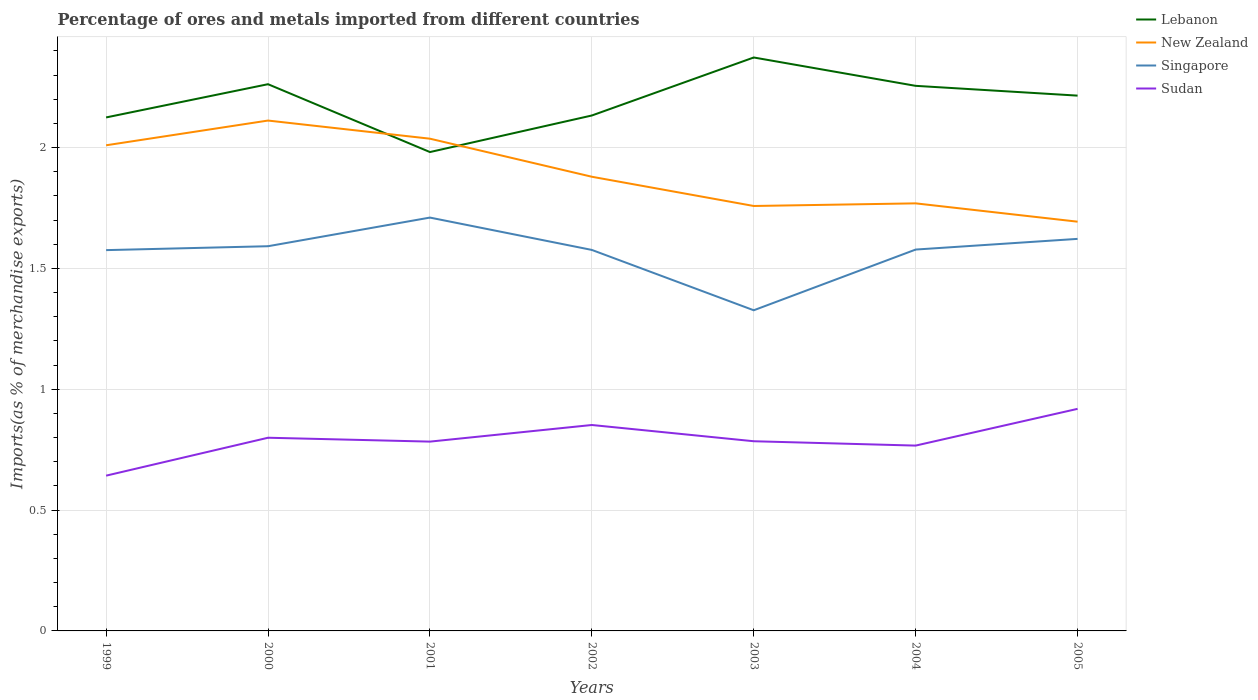Across all years, what is the maximum percentage of imports to different countries in Singapore?
Provide a short and direct response. 1.33. What is the total percentage of imports to different countries in Singapore in the graph?
Ensure brevity in your answer.  0.09. What is the difference between the highest and the second highest percentage of imports to different countries in Lebanon?
Offer a very short reply. 0.39. What is the difference between the highest and the lowest percentage of imports to different countries in New Zealand?
Your answer should be very brief. 3. Is the percentage of imports to different countries in Singapore strictly greater than the percentage of imports to different countries in Lebanon over the years?
Provide a short and direct response. Yes. How many years are there in the graph?
Make the answer very short. 7. Are the values on the major ticks of Y-axis written in scientific E-notation?
Give a very brief answer. No. Does the graph contain any zero values?
Provide a short and direct response. No. Where does the legend appear in the graph?
Give a very brief answer. Top right. How many legend labels are there?
Ensure brevity in your answer.  4. What is the title of the graph?
Keep it short and to the point. Percentage of ores and metals imported from different countries. What is the label or title of the Y-axis?
Your response must be concise. Imports(as % of merchandise exports). What is the Imports(as % of merchandise exports) of Lebanon in 1999?
Your response must be concise. 2.12. What is the Imports(as % of merchandise exports) of New Zealand in 1999?
Your answer should be compact. 2.01. What is the Imports(as % of merchandise exports) of Singapore in 1999?
Your response must be concise. 1.58. What is the Imports(as % of merchandise exports) in Sudan in 1999?
Your answer should be compact. 0.64. What is the Imports(as % of merchandise exports) of Lebanon in 2000?
Make the answer very short. 2.26. What is the Imports(as % of merchandise exports) of New Zealand in 2000?
Your answer should be very brief. 2.11. What is the Imports(as % of merchandise exports) in Singapore in 2000?
Your answer should be very brief. 1.59. What is the Imports(as % of merchandise exports) of Sudan in 2000?
Your answer should be compact. 0.8. What is the Imports(as % of merchandise exports) of Lebanon in 2001?
Offer a very short reply. 1.98. What is the Imports(as % of merchandise exports) in New Zealand in 2001?
Your answer should be very brief. 2.04. What is the Imports(as % of merchandise exports) of Singapore in 2001?
Provide a short and direct response. 1.71. What is the Imports(as % of merchandise exports) in Sudan in 2001?
Your answer should be very brief. 0.78. What is the Imports(as % of merchandise exports) in Lebanon in 2002?
Your response must be concise. 2.13. What is the Imports(as % of merchandise exports) in New Zealand in 2002?
Your response must be concise. 1.88. What is the Imports(as % of merchandise exports) in Singapore in 2002?
Give a very brief answer. 1.58. What is the Imports(as % of merchandise exports) of Sudan in 2002?
Your response must be concise. 0.85. What is the Imports(as % of merchandise exports) in Lebanon in 2003?
Your answer should be very brief. 2.37. What is the Imports(as % of merchandise exports) of New Zealand in 2003?
Your response must be concise. 1.76. What is the Imports(as % of merchandise exports) in Singapore in 2003?
Offer a very short reply. 1.33. What is the Imports(as % of merchandise exports) of Sudan in 2003?
Offer a terse response. 0.78. What is the Imports(as % of merchandise exports) in Lebanon in 2004?
Give a very brief answer. 2.26. What is the Imports(as % of merchandise exports) in New Zealand in 2004?
Provide a succinct answer. 1.77. What is the Imports(as % of merchandise exports) of Singapore in 2004?
Your answer should be compact. 1.58. What is the Imports(as % of merchandise exports) of Sudan in 2004?
Provide a succinct answer. 0.77. What is the Imports(as % of merchandise exports) in Lebanon in 2005?
Your answer should be very brief. 2.21. What is the Imports(as % of merchandise exports) in New Zealand in 2005?
Provide a succinct answer. 1.69. What is the Imports(as % of merchandise exports) in Singapore in 2005?
Make the answer very short. 1.62. What is the Imports(as % of merchandise exports) of Sudan in 2005?
Provide a short and direct response. 0.92. Across all years, what is the maximum Imports(as % of merchandise exports) of Lebanon?
Your response must be concise. 2.37. Across all years, what is the maximum Imports(as % of merchandise exports) of New Zealand?
Ensure brevity in your answer.  2.11. Across all years, what is the maximum Imports(as % of merchandise exports) of Singapore?
Your answer should be very brief. 1.71. Across all years, what is the maximum Imports(as % of merchandise exports) of Sudan?
Your answer should be compact. 0.92. Across all years, what is the minimum Imports(as % of merchandise exports) in Lebanon?
Make the answer very short. 1.98. Across all years, what is the minimum Imports(as % of merchandise exports) in New Zealand?
Your answer should be compact. 1.69. Across all years, what is the minimum Imports(as % of merchandise exports) of Singapore?
Your answer should be compact. 1.33. Across all years, what is the minimum Imports(as % of merchandise exports) in Sudan?
Keep it short and to the point. 0.64. What is the total Imports(as % of merchandise exports) of Lebanon in the graph?
Offer a very short reply. 15.34. What is the total Imports(as % of merchandise exports) of New Zealand in the graph?
Make the answer very short. 13.26. What is the total Imports(as % of merchandise exports) in Singapore in the graph?
Your response must be concise. 10.98. What is the total Imports(as % of merchandise exports) in Sudan in the graph?
Provide a succinct answer. 5.55. What is the difference between the Imports(as % of merchandise exports) of Lebanon in 1999 and that in 2000?
Your answer should be very brief. -0.14. What is the difference between the Imports(as % of merchandise exports) in New Zealand in 1999 and that in 2000?
Your answer should be very brief. -0.1. What is the difference between the Imports(as % of merchandise exports) in Singapore in 1999 and that in 2000?
Your response must be concise. -0.02. What is the difference between the Imports(as % of merchandise exports) of Sudan in 1999 and that in 2000?
Your answer should be very brief. -0.16. What is the difference between the Imports(as % of merchandise exports) in Lebanon in 1999 and that in 2001?
Keep it short and to the point. 0.14. What is the difference between the Imports(as % of merchandise exports) of New Zealand in 1999 and that in 2001?
Ensure brevity in your answer.  -0.03. What is the difference between the Imports(as % of merchandise exports) of Singapore in 1999 and that in 2001?
Give a very brief answer. -0.13. What is the difference between the Imports(as % of merchandise exports) in Sudan in 1999 and that in 2001?
Ensure brevity in your answer.  -0.14. What is the difference between the Imports(as % of merchandise exports) of Lebanon in 1999 and that in 2002?
Keep it short and to the point. -0.01. What is the difference between the Imports(as % of merchandise exports) in New Zealand in 1999 and that in 2002?
Your answer should be compact. 0.13. What is the difference between the Imports(as % of merchandise exports) of Singapore in 1999 and that in 2002?
Keep it short and to the point. -0. What is the difference between the Imports(as % of merchandise exports) in Sudan in 1999 and that in 2002?
Provide a succinct answer. -0.21. What is the difference between the Imports(as % of merchandise exports) in Lebanon in 1999 and that in 2003?
Provide a short and direct response. -0.25. What is the difference between the Imports(as % of merchandise exports) of New Zealand in 1999 and that in 2003?
Your answer should be very brief. 0.25. What is the difference between the Imports(as % of merchandise exports) in Singapore in 1999 and that in 2003?
Your answer should be compact. 0.25. What is the difference between the Imports(as % of merchandise exports) of Sudan in 1999 and that in 2003?
Provide a succinct answer. -0.14. What is the difference between the Imports(as % of merchandise exports) of Lebanon in 1999 and that in 2004?
Your response must be concise. -0.13. What is the difference between the Imports(as % of merchandise exports) of New Zealand in 1999 and that in 2004?
Your answer should be very brief. 0.24. What is the difference between the Imports(as % of merchandise exports) of Singapore in 1999 and that in 2004?
Your answer should be compact. -0. What is the difference between the Imports(as % of merchandise exports) in Sudan in 1999 and that in 2004?
Offer a terse response. -0.12. What is the difference between the Imports(as % of merchandise exports) of Lebanon in 1999 and that in 2005?
Your response must be concise. -0.09. What is the difference between the Imports(as % of merchandise exports) of New Zealand in 1999 and that in 2005?
Provide a succinct answer. 0.32. What is the difference between the Imports(as % of merchandise exports) of Singapore in 1999 and that in 2005?
Your answer should be compact. -0.05. What is the difference between the Imports(as % of merchandise exports) of Sudan in 1999 and that in 2005?
Ensure brevity in your answer.  -0.28. What is the difference between the Imports(as % of merchandise exports) of Lebanon in 2000 and that in 2001?
Make the answer very short. 0.28. What is the difference between the Imports(as % of merchandise exports) of New Zealand in 2000 and that in 2001?
Offer a terse response. 0.07. What is the difference between the Imports(as % of merchandise exports) of Singapore in 2000 and that in 2001?
Provide a succinct answer. -0.12. What is the difference between the Imports(as % of merchandise exports) in Sudan in 2000 and that in 2001?
Your response must be concise. 0.02. What is the difference between the Imports(as % of merchandise exports) of Lebanon in 2000 and that in 2002?
Give a very brief answer. 0.13. What is the difference between the Imports(as % of merchandise exports) in New Zealand in 2000 and that in 2002?
Ensure brevity in your answer.  0.23. What is the difference between the Imports(as % of merchandise exports) of Singapore in 2000 and that in 2002?
Keep it short and to the point. 0.02. What is the difference between the Imports(as % of merchandise exports) in Sudan in 2000 and that in 2002?
Your answer should be compact. -0.05. What is the difference between the Imports(as % of merchandise exports) of Lebanon in 2000 and that in 2003?
Your answer should be compact. -0.11. What is the difference between the Imports(as % of merchandise exports) in New Zealand in 2000 and that in 2003?
Your answer should be very brief. 0.35. What is the difference between the Imports(as % of merchandise exports) of Singapore in 2000 and that in 2003?
Your answer should be very brief. 0.27. What is the difference between the Imports(as % of merchandise exports) of Sudan in 2000 and that in 2003?
Provide a succinct answer. 0.01. What is the difference between the Imports(as % of merchandise exports) in Lebanon in 2000 and that in 2004?
Keep it short and to the point. 0.01. What is the difference between the Imports(as % of merchandise exports) of New Zealand in 2000 and that in 2004?
Make the answer very short. 0.34. What is the difference between the Imports(as % of merchandise exports) of Singapore in 2000 and that in 2004?
Provide a short and direct response. 0.01. What is the difference between the Imports(as % of merchandise exports) of Sudan in 2000 and that in 2004?
Make the answer very short. 0.03. What is the difference between the Imports(as % of merchandise exports) in Lebanon in 2000 and that in 2005?
Provide a succinct answer. 0.05. What is the difference between the Imports(as % of merchandise exports) of New Zealand in 2000 and that in 2005?
Ensure brevity in your answer.  0.42. What is the difference between the Imports(as % of merchandise exports) in Singapore in 2000 and that in 2005?
Provide a succinct answer. -0.03. What is the difference between the Imports(as % of merchandise exports) of Sudan in 2000 and that in 2005?
Offer a very short reply. -0.12. What is the difference between the Imports(as % of merchandise exports) of Lebanon in 2001 and that in 2002?
Offer a very short reply. -0.15. What is the difference between the Imports(as % of merchandise exports) in New Zealand in 2001 and that in 2002?
Offer a terse response. 0.16. What is the difference between the Imports(as % of merchandise exports) in Singapore in 2001 and that in 2002?
Ensure brevity in your answer.  0.13. What is the difference between the Imports(as % of merchandise exports) of Sudan in 2001 and that in 2002?
Offer a very short reply. -0.07. What is the difference between the Imports(as % of merchandise exports) in Lebanon in 2001 and that in 2003?
Your response must be concise. -0.39. What is the difference between the Imports(as % of merchandise exports) of New Zealand in 2001 and that in 2003?
Make the answer very short. 0.28. What is the difference between the Imports(as % of merchandise exports) in Singapore in 2001 and that in 2003?
Make the answer very short. 0.38. What is the difference between the Imports(as % of merchandise exports) in Sudan in 2001 and that in 2003?
Provide a succinct answer. -0. What is the difference between the Imports(as % of merchandise exports) in Lebanon in 2001 and that in 2004?
Your response must be concise. -0.27. What is the difference between the Imports(as % of merchandise exports) in New Zealand in 2001 and that in 2004?
Your response must be concise. 0.27. What is the difference between the Imports(as % of merchandise exports) in Singapore in 2001 and that in 2004?
Offer a terse response. 0.13. What is the difference between the Imports(as % of merchandise exports) in Sudan in 2001 and that in 2004?
Make the answer very short. 0.02. What is the difference between the Imports(as % of merchandise exports) in Lebanon in 2001 and that in 2005?
Ensure brevity in your answer.  -0.23. What is the difference between the Imports(as % of merchandise exports) of New Zealand in 2001 and that in 2005?
Keep it short and to the point. 0.34. What is the difference between the Imports(as % of merchandise exports) of Singapore in 2001 and that in 2005?
Offer a very short reply. 0.09. What is the difference between the Imports(as % of merchandise exports) of Sudan in 2001 and that in 2005?
Provide a succinct answer. -0.14. What is the difference between the Imports(as % of merchandise exports) of Lebanon in 2002 and that in 2003?
Make the answer very short. -0.24. What is the difference between the Imports(as % of merchandise exports) of New Zealand in 2002 and that in 2003?
Offer a very short reply. 0.12. What is the difference between the Imports(as % of merchandise exports) of Singapore in 2002 and that in 2003?
Keep it short and to the point. 0.25. What is the difference between the Imports(as % of merchandise exports) of Sudan in 2002 and that in 2003?
Make the answer very short. 0.07. What is the difference between the Imports(as % of merchandise exports) in Lebanon in 2002 and that in 2004?
Offer a terse response. -0.12. What is the difference between the Imports(as % of merchandise exports) of New Zealand in 2002 and that in 2004?
Provide a succinct answer. 0.11. What is the difference between the Imports(as % of merchandise exports) of Singapore in 2002 and that in 2004?
Make the answer very short. -0. What is the difference between the Imports(as % of merchandise exports) of Sudan in 2002 and that in 2004?
Provide a short and direct response. 0.09. What is the difference between the Imports(as % of merchandise exports) of Lebanon in 2002 and that in 2005?
Provide a short and direct response. -0.08. What is the difference between the Imports(as % of merchandise exports) in New Zealand in 2002 and that in 2005?
Offer a terse response. 0.19. What is the difference between the Imports(as % of merchandise exports) in Singapore in 2002 and that in 2005?
Your answer should be compact. -0.05. What is the difference between the Imports(as % of merchandise exports) of Sudan in 2002 and that in 2005?
Your answer should be very brief. -0.07. What is the difference between the Imports(as % of merchandise exports) of Lebanon in 2003 and that in 2004?
Your response must be concise. 0.12. What is the difference between the Imports(as % of merchandise exports) in New Zealand in 2003 and that in 2004?
Provide a succinct answer. -0.01. What is the difference between the Imports(as % of merchandise exports) of Singapore in 2003 and that in 2004?
Your response must be concise. -0.25. What is the difference between the Imports(as % of merchandise exports) of Sudan in 2003 and that in 2004?
Make the answer very short. 0.02. What is the difference between the Imports(as % of merchandise exports) of Lebanon in 2003 and that in 2005?
Your response must be concise. 0.16. What is the difference between the Imports(as % of merchandise exports) of New Zealand in 2003 and that in 2005?
Give a very brief answer. 0.06. What is the difference between the Imports(as % of merchandise exports) in Singapore in 2003 and that in 2005?
Your answer should be very brief. -0.3. What is the difference between the Imports(as % of merchandise exports) of Sudan in 2003 and that in 2005?
Provide a succinct answer. -0.13. What is the difference between the Imports(as % of merchandise exports) in Lebanon in 2004 and that in 2005?
Ensure brevity in your answer.  0.04. What is the difference between the Imports(as % of merchandise exports) in New Zealand in 2004 and that in 2005?
Your answer should be very brief. 0.08. What is the difference between the Imports(as % of merchandise exports) in Singapore in 2004 and that in 2005?
Provide a short and direct response. -0.04. What is the difference between the Imports(as % of merchandise exports) in Sudan in 2004 and that in 2005?
Offer a terse response. -0.15. What is the difference between the Imports(as % of merchandise exports) in Lebanon in 1999 and the Imports(as % of merchandise exports) in New Zealand in 2000?
Provide a short and direct response. 0.01. What is the difference between the Imports(as % of merchandise exports) in Lebanon in 1999 and the Imports(as % of merchandise exports) in Singapore in 2000?
Keep it short and to the point. 0.53. What is the difference between the Imports(as % of merchandise exports) of Lebanon in 1999 and the Imports(as % of merchandise exports) of Sudan in 2000?
Offer a terse response. 1.33. What is the difference between the Imports(as % of merchandise exports) of New Zealand in 1999 and the Imports(as % of merchandise exports) of Singapore in 2000?
Make the answer very short. 0.42. What is the difference between the Imports(as % of merchandise exports) in New Zealand in 1999 and the Imports(as % of merchandise exports) in Sudan in 2000?
Your answer should be compact. 1.21. What is the difference between the Imports(as % of merchandise exports) of Singapore in 1999 and the Imports(as % of merchandise exports) of Sudan in 2000?
Your answer should be compact. 0.78. What is the difference between the Imports(as % of merchandise exports) in Lebanon in 1999 and the Imports(as % of merchandise exports) in New Zealand in 2001?
Ensure brevity in your answer.  0.09. What is the difference between the Imports(as % of merchandise exports) of Lebanon in 1999 and the Imports(as % of merchandise exports) of Singapore in 2001?
Offer a very short reply. 0.41. What is the difference between the Imports(as % of merchandise exports) in Lebanon in 1999 and the Imports(as % of merchandise exports) in Sudan in 2001?
Provide a succinct answer. 1.34. What is the difference between the Imports(as % of merchandise exports) of New Zealand in 1999 and the Imports(as % of merchandise exports) of Singapore in 2001?
Offer a very short reply. 0.3. What is the difference between the Imports(as % of merchandise exports) in New Zealand in 1999 and the Imports(as % of merchandise exports) in Sudan in 2001?
Your answer should be very brief. 1.23. What is the difference between the Imports(as % of merchandise exports) of Singapore in 1999 and the Imports(as % of merchandise exports) of Sudan in 2001?
Your response must be concise. 0.79. What is the difference between the Imports(as % of merchandise exports) in Lebanon in 1999 and the Imports(as % of merchandise exports) in New Zealand in 2002?
Make the answer very short. 0.25. What is the difference between the Imports(as % of merchandise exports) in Lebanon in 1999 and the Imports(as % of merchandise exports) in Singapore in 2002?
Your answer should be very brief. 0.55. What is the difference between the Imports(as % of merchandise exports) of Lebanon in 1999 and the Imports(as % of merchandise exports) of Sudan in 2002?
Offer a terse response. 1.27. What is the difference between the Imports(as % of merchandise exports) of New Zealand in 1999 and the Imports(as % of merchandise exports) of Singapore in 2002?
Ensure brevity in your answer.  0.43. What is the difference between the Imports(as % of merchandise exports) of New Zealand in 1999 and the Imports(as % of merchandise exports) of Sudan in 2002?
Your answer should be compact. 1.16. What is the difference between the Imports(as % of merchandise exports) of Singapore in 1999 and the Imports(as % of merchandise exports) of Sudan in 2002?
Provide a short and direct response. 0.72. What is the difference between the Imports(as % of merchandise exports) in Lebanon in 1999 and the Imports(as % of merchandise exports) in New Zealand in 2003?
Your response must be concise. 0.37. What is the difference between the Imports(as % of merchandise exports) in Lebanon in 1999 and the Imports(as % of merchandise exports) in Singapore in 2003?
Offer a terse response. 0.8. What is the difference between the Imports(as % of merchandise exports) of Lebanon in 1999 and the Imports(as % of merchandise exports) of Sudan in 2003?
Offer a terse response. 1.34. What is the difference between the Imports(as % of merchandise exports) in New Zealand in 1999 and the Imports(as % of merchandise exports) in Singapore in 2003?
Offer a terse response. 0.68. What is the difference between the Imports(as % of merchandise exports) in New Zealand in 1999 and the Imports(as % of merchandise exports) in Sudan in 2003?
Provide a succinct answer. 1.22. What is the difference between the Imports(as % of merchandise exports) in Singapore in 1999 and the Imports(as % of merchandise exports) in Sudan in 2003?
Provide a succinct answer. 0.79. What is the difference between the Imports(as % of merchandise exports) of Lebanon in 1999 and the Imports(as % of merchandise exports) of New Zealand in 2004?
Provide a succinct answer. 0.36. What is the difference between the Imports(as % of merchandise exports) in Lebanon in 1999 and the Imports(as % of merchandise exports) in Singapore in 2004?
Offer a very short reply. 0.55. What is the difference between the Imports(as % of merchandise exports) in Lebanon in 1999 and the Imports(as % of merchandise exports) in Sudan in 2004?
Keep it short and to the point. 1.36. What is the difference between the Imports(as % of merchandise exports) in New Zealand in 1999 and the Imports(as % of merchandise exports) in Singapore in 2004?
Offer a very short reply. 0.43. What is the difference between the Imports(as % of merchandise exports) of New Zealand in 1999 and the Imports(as % of merchandise exports) of Sudan in 2004?
Offer a terse response. 1.24. What is the difference between the Imports(as % of merchandise exports) of Singapore in 1999 and the Imports(as % of merchandise exports) of Sudan in 2004?
Offer a terse response. 0.81. What is the difference between the Imports(as % of merchandise exports) in Lebanon in 1999 and the Imports(as % of merchandise exports) in New Zealand in 2005?
Your answer should be very brief. 0.43. What is the difference between the Imports(as % of merchandise exports) in Lebanon in 1999 and the Imports(as % of merchandise exports) in Singapore in 2005?
Provide a short and direct response. 0.5. What is the difference between the Imports(as % of merchandise exports) in Lebanon in 1999 and the Imports(as % of merchandise exports) in Sudan in 2005?
Offer a very short reply. 1.21. What is the difference between the Imports(as % of merchandise exports) of New Zealand in 1999 and the Imports(as % of merchandise exports) of Singapore in 2005?
Offer a terse response. 0.39. What is the difference between the Imports(as % of merchandise exports) of New Zealand in 1999 and the Imports(as % of merchandise exports) of Sudan in 2005?
Give a very brief answer. 1.09. What is the difference between the Imports(as % of merchandise exports) of Singapore in 1999 and the Imports(as % of merchandise exports) of Sudan in 2005?
Provide a short and direct response. 0.66. What is the difference between the Imports(as % of merchandise exports) in Lebanon in 2000 and the Imports(as % of merchandise exports) in New Zealand in 2001?
Your response must be concise. 0.23. What is the difference between the Imports(as % of merchandise exports) of Lebanon in 2000 and the Imports(as % of merchandise exports) of Singapore in 2001?
Give a very brief answer. 0.55. What is the difference between the Imports(as % of merchandise exports) in Lebanon in 2000 and the Imports(as % of merchandise exports) in Sudan in 2001?
Ensure brevity in your answer.  1.48. What is the difference between the Imports(as % of merchandise exports) in New Zealand in 2000 and the Imports(as % of merchandise exports) in Singapore in 2001?
Make the answer very short. 0.4. What is the difference between the Imports(as % of merchandise exports) in New Zealand in 2000 and the Imports(as % of merchandise exports) in Sudan in 2001?
Provide a short and direct response. 1.33. What is the difference between the Imports(as % of merchandise exports) of Singapore in 2000 and the Imports(as % of merchandise exports) of Sudan in 2001?
Offer a terse response. 0.81. What is the difference between the Imports(as % of merchandise exports) of Lebanon in 2000 and the Imports(as % of merchandise exports) of New Zealand in 2002?
Provide a short and direct response. 0.38. What is the difference between the Imports(as % of merchandise exports) in Lebanon in 2000 and the Imports(as % of merchandise exports) in Singapore in 2002?
Provide a succinct answer. 0.69. What is the difference between the Imports(as % of merchandise exports) in Lebanon in 2000 and the Imports(as % of merchandise exports) in Sudan in 2002?
Your answer should be very brief. 1.41. What is the difference between the Imports(as % of merchandise exports) of New Zealand in 2000 and the Imports(as % of merchandise exports) of Singapore in 2002?
Ensure brevity in your answer.  0.54. What is the difference between the Imports(as % of merchandise exports) of New Zealand in 2000 and the Imports(as % of merchandise exports) of Sudan in 2002?
Your answer should be very brief. 1.26. What is the difference between the Imports(as % of merchandise exports) in Singapore in 2000 and the Imports(as % of merchandise exports) in Sudan in 2002?
Your response must be concise. 0.74. What is the difference between the Imports(as % of merchandise exports) of Lebanon in 2000 and the Imports(as % of merchandise exports) of New Zealand in 2003?
Offer a terse response. 0.5. What is the difference between the Imports(as % of merchandise exports) of Lebanon in 2000 and the Imports(as % of merchandise exports) of Singapore in 2003?
Provide a succinct answer. 0.94. What is the difference between the Imports(as % of merchandise exports) of Lebanon in 2000 and the Imports(as % of merchandise exports) of Sudan in 2003?
Ensure brevity in your answer.  1.48. What is the difference between the Imports(as % of merchandise exports) of New Zealand in 2000 and the Imports(as % of merchandise exports) of Singapore in 2003?
Your response must be concise. 0.79. What is the difference between the Imports(as % of merchandise exports) in New Zealand in 2000 and the Imports(as % of merchandise exports) in Sudan in 2003?
Your answer should be very brief. 1.33. What is the difference between the Imports(as % of merchandise exports) of Singapore in 2000 and the Imports(as % of merchandise exports) of Sudan in 2003?
Make the answer very short. 0.81. What is the difference between the Imports(as % of merchandise exports) of Lebanon in 2000 and the Imports(as % of merchandise exports) of New Zealand in 2004?
Provide a short and direct response. 0.49. What is the difference between the Imports(as % of merchandise exports) in Lebanon in 2000 and the Imports(as % of merchandise exports) in Singapore in 2004?
Give a very brief answer. 0.68. What is the difference between the Imports(as % of merchandise exports) of Lebanon in 2000 and the Imports(as % of merchandise exports) of Sudan in 2004?
Ensure brevity in your answer.  1.5. What is the difference between the Imports(as % of merchandise exports) in New Zealand in 2000 and the Imports(as % of merchandise exports) in Singapore in 2004?
Ensure brevity in your answer.  0.53. What is the difference between the Imports(as % of merchandise exports) of New Zealand in 2000 and the Imports(as % of merchandise exports) of Sudan in 2004?
Provide a short and direct response. 1.34. What is the difference between the Imports(as % of merchandise exports) of Singapore in 2000 and the Imports(as % of merchandise exports) of Sudan in 2004?
Ensure brevity in your answer.  0.82. What is the difference between the Imports(as % of merchandise exports) in Lebanon in 2000 and the Imports(as % of merchandise exports) in New Zealand in 2005?
Your answer should be very brief. 0.57. What is the difference between the Imports(as % of merchandise exports) in Lebanon in 2000 and the Imports(as % of merchandise exports) in Singapore in 2005?
Give a very brief answer. 0.64. What is the difference between the Imports(as % of merchandise exports) in Lebanon in 2000 and the Imports(as % of merchandise exports) in Sudan in 2005?
Make the answer very short. 1.34. What is the difference between the Imports(as % of merchandise exports) of New Zealand in 2000 and the Imports(as % of merchandise exports) of Singapore in 2005?
Make the answer very short. 0.49. What is the difference between the Imports(as % of merchandise exports) in New Zealand in 2000 and the Imports(as % of merchandise exports) in Sudan in 2005?
Your answer should be compact. 1.19. What is the difference between the Imports(as % of merchandise exports) of Singapore in 2000 and the Imports(as % of merchandise exports) of Sudan in 2005?
Give a very brief answer. 0.67. What is the difference between the Imports(as % of merchandise exports) of Lebanon in 2001 and the Imports(as % of merchandise exports) of New Zealand in 2002?
Provide a short and direct response. 0.1. What is the difference between the Imports(as % of merchandise exports) in Lebanon in 2001 and the Imports(as % of merchandise exports) in Singapore in 2002?
Offer a terse response. 0.41. What is the difference between the Imports(as % of merchandise exports) in Lebanon in 2001 and the Imports(as % of merchandise exports) in Sudan in 2002?
Make the answer very short. 1.13. What is the difference between the Imports(as % of merchandise exports) in New Zealand in 2001 and the Imports(as % of merchandise exports) in Singapore in 2002?
Your answer should be very brief. 0.46. What is the difference between the Imports(as % of merchandise exports) of New Zealand in 2001 and the Imports(as % of merchandise exports) of Sudan in 2002?
Provide a short and direct response. 1.18. What is the difference between the Imports(as % of merchandise exports) in Singapore in 2001 and the Imports(as % of merchandise exports) in Sudan in 2002?
Your answer should be compact. 0.86. What is the difference between the Imports(as % of merchandise exports) in Lebanon in 2001 and the Imports(as % of merchandise exports) in New Zealand in 2003?
Offer a terse response. 0.22. What is the difference between the Imports(as % of merchandise exports) in Lebanon in 2001 and the Imports(as % of merchandise exports) in Singapore in 2003?
Your response must be concise. 0.65. What is the difference between the Imports(as % of merchandise exports) of Lebanon in 2001 and the Imports(as % of merchandise exports) of Sudan in 2003?
Your answer should be compact. 1.2. What is the difference between the Imports(as % of merchandise exports) in New Zealand in 2001 and the Imports(as % of merchandise exports) in Singapore in 2003?
Make the answer very short. 0.71. What is the difference between the Imports(as % of merchandise exports) in New Zealand in 2001 and the Imports(as % of merchandise exports) in Sudan in 2003?
Offer a terse response. 1.25. What is the difference between the Imports(as % of merchandise exports) of Singapore in 2001 and the Imports(as % of merchandise exports) of Sudan in 2003?
Your response must be concise. 0.93. What is the difference between the Imports(as % of merchandise exports) in Lebanon in 2001 and the Imports(as % of merchandise exports) in New Zealand in 2004?
Your answer should be compact. 0.21. What is the difference between the Imports(as % of merchandise exports) in Lebanon in 2001 and the Imports(as % of merchandise exports) in Singapore in 2004?
Your answer should be very brief. 0.4. What is the difference between the Imports(as % of merchandise exports) of Lebanon in 2001 and the Imports(as % of merchandise exports) of Sudan in 2004?
Your answer should be compact. 1.21. What is the difference between the Imports(as % of merchandise exports) of New Zealand in 2001 and the Imports(as % of merchandise exports) of Singapore in 2004?
Ensure brevity in your answer.  0.46. What is the difference between the Imports(as % of merchandise exports) of New Zealand in 2001 and the Imports(as % of merchandise exports) of Sudan in 2004?
Offer a very short reply. 1.27. What is the difference between the Imports(as % of merchandise exports) of Singapore in 2001 and the Imports(as % of merchandise exports) of Sudan in 2004?
Provide a short and direct response. 0.94. What is the difference between the Imports(as % of merchandise exports) in Lebanon in 2001 and the Imports(as % of merchandise exports) in New Zealand in 2005?
Keep it short and to the point. 0.29. What is the difference between the Imports(as % of merchandise exports) of Lebanon in 2001 and the Imports(as % of merchandise exports) of Singapore in 2005?
Your response must be concise. 0.36. What is the difference between the Imports(as % of merchandise exports) in Lebanon in 2001 and the Imports(as % of merchandise exports) in Sudan in 2005?
Ensure brevity in your answer.  1.06. What is the difference between the Imports(as % of merchandise exports) in New Zealand in 2001 and the Imports(as % of merchandise exports) in Singapore in 2005?
Give a very brief answer. 0.41. What is the difference between the Imports(as % of merchandise exports) of New Zealand in 2001 and the Imports(as % of merchandise exports) of Sudan in 2005?
Provide a short and direct response. 1.12. What is the difference between the Imports(as % of merchandise exports) of Singapore in 2001 and the Imports(as % of merchandise exports) of Sudan in 2005?
Offer a very short reply. 0.79. What is the difference between the Imports(as % of merchandise exports) in Lebanon in 2002 and the Imports(as % of merchandise exports) in New Zealand in 2003?
Offer a terse response. 0.37. What is the difference between the Imports(as % of merchandise exports) in Lebanon in 2002 and the Imports(as % of merchandise exports) in Singapore in 2003?
Provide a succinct answer. 0.81. What is the difference between the Imports(as % of merchandise exports) of Lebanon in 2002 and the Imports(as % of merchandise exports) of Sudan in 2003?
Your response must be concise. 1.35. What is the difference between the Imports(as % of merchandise exports) in New Zealand in 2002 and the Imports(as % of merchandise exports) in Singapore in 2003?
Give a very brief answer. 0.55. What is the difference between the Imports(as % of merchandise exports) in New Zealand in 2002 and the Imports(as % of merchandise exports) in Sudan in 2003?
Provide a short and direct response. 1.09. What is the difference between the Imports(as % of merchandise exports) in Singapore in 2002 and the Imports(as % of merchandise exports) in Sudan in 2003?
Make the answer very short. 0.79. What is the difference between the Imports(as % of merchandise exports) of Lebanon in 2002 and the Imports(as % of merchandise exports) of New Zealand in 2004?
Make the answer very short. 0.36. What is the difference between the Imports(as % of merchandise exports) in Lebanon in 2002 and the Imports(as % of merchandise exports) in Singapore in 2004?
Your response must be concise. 0.55. What is the difference between the Imports(as % of merchandise exports) in Lebanon in 2002 and the Imports(as % of merchandise exports) in Sudan in 2004?
Provide a succinct answer. 1.37. What is the difference between the Imports(as % of merchandise exports) of New Zealand in 2002 and the Imports(as % of merchandise exports) of Singapore in 2004?
Keep it short and to the point. 0.3. What is the difference between the Imports(as % of merchandise exports) of New Zealand in 2002 and the Imports(as % of merchandise exports) of Sudan in 2004?
Make the answer very short. 1.11. What is the difference between the Imports(as % of merchandise exports) of Singapore in 2002 and the Imports(as % of merchandise exports) of Sudan in 2004?
Your answer should be very brief. 0.81. What is the difference between the Imports(as % of merchandise exports) of Lebanon in 2002 and the Imports(as % of merchandise exports) of New Zealand in 2005?
Your response must be concise. 0.44. What is the difference between the Imports(as % of merchandise exports) in Lebanon in 2002 and the Imports(as % of merchandise exports) in Singapore in 2005?
Provide a short and direct response. 0.51. What is the difference between the Imports(as % of merchandise exports) of Lebanon in 2002 and the Imports(as % of merchandise exports) of Sudan in 2005?
Ensure brevity in your answer.  1.21. What is the difference between the Imports(as % of merchandise exports) of New Zealand in 2002 and the Imports(as % of merchandise exports) of Singapore in 2005?
Your answer should be compact. 0.26. What is the difference between the Imports(as % of merchandise exports) of New Zealand in 2002 and the Imports(as % of merchandise exports) of Sudan in 2005?
Offer a very short reply. 0.96. What is the difference between the Imports(as % of merchandise exports) in Singapore in 2002 and the Imports(as % of merchandise exports) in Sudan in 2005?
Provide a succinct answer. 0.66. What is the difference between the Imports(as % of merchandise exports) in Lebanon in 2003 and the Imports(as % of merchandise exports) in New Zealand in 2004?
Offer a very short reply. 0.6. What is the difference between the Imports(as % of merchandise exports) of Lebanon in 2003 and the Imports(as % of merchandise exports) of Singapore in 2004?
Offer a very short reply. 0.79. What is the difference between the Imports(as % of merchandise exports) in Lebanon in 2003 and the Imports(as % of merchandise exports) in Sudan in 2004?
Give a very brief answer. 1.61. What is the difference between the Imports(as % of merchandise exports) in New Zealand in 2003 and the Imports(as % of merchandise exports) in Singapore in 2004?
Offer a terse response. 0.18. What is the difference between the Imports(as % of merchandise exports) of Singapore in 2003 and the Imports(as % of merchandise exports) of Sudan in 2004?
Provide a short and direct response. 0.56. What is the difference between the Imports(as % of merchandise exports) of Lebanon in 2003 and the Imports(as % of merchandise exports) of New Zealand in 2005?
Ensure brevity in your answer.  0.68. What is the difference between the Imports(as % of merchandise exports) in Lebanon in 2003 and the Imports(as % of merchandise exports) in Singapore in 2005?
Provide a succinct answer. 0.75. What is the difference between the Imports(as % of merchandise exports) in Lebanon in 2003 and the Imports(as % of merchandise exports) in Sudan in 2005?
Provide a succinct answer. 1.45. What is the difference between the Imports(as % of merchandise exports) of New Zealand in 2003 and the Imports(as % of merchandise exports) of Singapore in 2005?
Provide a succinct answer. 0.14. What is the difference between the Imports(as % of merchandise exports) of New Zealand in 2003 and the Imports(as % of merchandise exports) of Sudan in 2005?
Provide a succinct answer. 0.84. What is the difference between the Imports(as % of merchandise exports) in Singapore in 2003 and the Imports(as % of merchandise exports) in Sudan in 2005?
Provide a succinct answer. 0.41. What is the difference between the Imports(as % of merchandise exports) of Lebanon in 2004 and the Imports(as % of merchandise exports) of New Zealand in 2005?
Make the answer very short. 0.56. What is the difference between the Imports(as % of merchandise exports) in Lebanon in 2004 and the Imports(as % of merchandise exports) in Singapore in 2005?
Your answer should be compact. 0.63. What is the difference between the Imports(as % of merchandise exports) in Lebanon in 2004 and the Imports(as % of merchandise exports) in Sudan in 2005?
Ensure brevity in your answer.  1.34. What is the difference between the Imports(as % of merchandise exports) in New Zealand in 2004 and the Imports(as % of merchandise exports) in Singapore in 2005?
Give a very brief answer. 0.15. What is the difference between the Imports(as % of merchandise exports) in New Zealand in 2004 and the Imports(as % of merchandise exports) in Sudan in 2005?
Keep it short and to the point. 0.85. What is the difference between the Imports(as % of merchandise exports) in Singapore in 2004 and the Imports(as % of merchandise exports) in Sudan in 2005?
Make the answer very short. 0.66. What is the average Imports(as % of merchandise exports) of Lebanon per year?
Provide a short and direct response. 2.19. What is the average Imports(as % of merchandise exports) in New Zealand per year?
Your answer should be compact. 1.89. What is the average Imports(as % of merchandise exports) in Singapore per year?
Your answer should be very brief. 1.57. What is the average Imports(as % of merchandise exports) in Sudan per year?
Ensure brevity in your answer.  0.79. In the year 1999, what is the difference between the Imports(as % of merchandise exports) of Lebanon and Imports(as % of merchandise exports) of New Zealand?
Your answer should be very brief. 0.12. In the year 1999, what is the difference between the Imports(as % of merchandise exports) of Lebanon and Imports(as % of merchandise exports) of Singapore?
Your answer should be very brief. 0.55. In the year 1999, what is the difference between the Imports(as % of merchandise exports) in Lebanon and Imports(as % of merchandise exports) in Sudan?
Offer a very short reply. 1.48. In the year 1999, what is the difference between the Imports(as % of merchandise exports) in New Zealand and Imports(as % of merchandise exports) in Singapore?
Your response must be concise. 0.43. In the year 1999, what is the difference between the Imports(as % of merchandise exports) in New Zealand and Imports(as % of merchandise exports) in Sudan?
Provide a short and direct response. 1.37. In the year 1999, what is the difference between the Imports(as % of merchandise exports) of Singapore and Imports(as % of merchandise exports) of Sudan?
Ensure brevity in your answer.  0.93. In the year 2000, what is the difference between the Imports(as % of merchandise exports) of Lebanon and Imports(as % of merchandise exports) of New Zealand?
Keep it short and to the point. 0.15. In the year 2000, what is the difference between the Imports(as % of merchandise exports) in Lebanon and Imports(as % of merchandise exports) in Singapore?
Your answer should be compact. 0.67. In the year 2000, what is the difference between the Imports(as % of merchandise exports) of Lebanon and Imports(as % of merchandise exports) of Sudan?
Offer a very short reply. 1.46. In the year 2000, what is the difference between the Imports(as % of merchandise exports) of New Zealand and Imports(as % of merchandise exports) of Singapore?
Ensure brevity in your answer.  0.52. In the year 2000, what is the difference between the Imports(as % of merchandise exports) of New Zealand and Imports(as % of merchandise exports) of Sudan?
Keep it short and to the point. 1.31. In the year 2000, what is the difference between the Imports(as % of merchandise exports) of Singapore and Imports(as % of merchandise exports) of Sudan?
Keep it short and to the point. 0.79. In the year 2001, what is the difference between the Imports(as % of merchandise exports) of Lebanon and Imports(as % of merchandise exports) of New Zealand?
Make the answer very short. -0.06. In the year 2001, what is the difference between the Imports(as % of merchandise exports) in Lebanon and Imports(as % of merchandise exports) in Singapore?
Give a very brief answer. 0.27. In the year 2001, what is the difference between the Imports(as % of merchandise exports) of Lebanon and Imports(as % of merchandise exports) of Sudan?
Offer a very short reply. 1.2. In the year 2001, what is the difference between the Imports(as % of merchandise exports) of New Zealand and Imports(as % of merchandise exports) of Singapore?
Your answer should be very brief. 0.33. In the year 2001, what is the difference between the Imports(as % of merchandise exports) in New Zealand and Imports(as % of merchandise exports) in Sudan?
Your response must be concise. 1.25. In the year 2001, what is the difference between the Imports(as % of merchandise exports) in Singapore and Imports(as % of merchandise exports) in Sudan?
Provide a succinct answer. 0.93. In the year 2002, what is the difference between the Imports(as % of merchandise exports) in Lebanon and Imports(as % of merchandise exports) in New Zealand?
Provide a succinct answer. 0.25. In the year 2002, what is the difference between the Imports(as % of merchandise exports) in Lebanon and Imports(as % of merchandise exports) in Singapore?
Ensure brevity in your answer.  0.56. In the year 2002, what is the difference between the Imports(as % of merchandise exports) in Lebanon and Imports(as % of merchandise exports) in Sudan?
Keep it short and to the point. 1.28. In the year 2002, what is the difference between the Imports(as % of merchandise exports) of New Zealand and Imports(as % of merchandise exports) of Singapore?
Provide a succinct answer. 0.3. In the year 2002, what is the difference between the Imports(as % of merchandise exports) in New Zealand and Imports(as % of merchandise exports) in Sudan?
Offer a very short reply. 1.03. In the year 2002, what is the difference between the Imports(as % of merchandise exports) of Singapore and Imports(as % of merchandise exports) of Sudan?
Make the answer very short. 0.72. In the year 2003, what is the difference between the Imports(as % of merchandise exports) in Lebanon and Imports(as % of merchandise exports) in New Zealand?
Keep it short and to the point. 0.61. In the year 2003, what is the difference between the Imports(as % of merchandise exports) in Lebanon and Imports(as % of merchandise exports) in Singapore?
Make the answer very short. 1.05. In the year 2003, what is the difference between the Imports(as % of merchandise exports) in Lebanon and Imports(as % of merchandise exports) in Sudan?
Your answer should be compact. 1.59. In the year 2003, what is the difference between the Imports(as % of merchandise exports) in New Zealand and Imports(as % of merchandise exports) in Singapore?
Give a very brief answer. 0.43. In the year 2003, what is the difference between the Imports(as % of merchandise exports) in New Zealand and Imports(as % of merchandise exports) in Sudan?
Keep it short and to the point. 0.97. In the year 2003, what is the difference between the Imports(as % of merchandise exports) of Singapore and Imports(as % of merchandise exports) of Sudan?
Your answer should be compact. 0.54. In the year 2004, what is the difference between the Imports(as % of merchandise exports) in Lebanon and Imports(as % of merchandise exports) in New Zealand?
Ensure brevity in your answer.  0.49. In the year 2004, what is the difference between the Imports(as % of merchandise exports) of Lebanon and Imports(as % of merchandise exports) of Singapore?
Your answer should be very brief. 0.68. In the year 2004, what is the difference between the Imports(as % of merchandise exports) of Lebanon and Imports(as % of merchandise exports) of Sudan?
Provide a short and direct response. 1.49. In the year 2004, what is the difference between the Imports(as % of merchandise exports) of New Zealand and Imports(as % of merchandise exports) of Singapore?
Your answer should be very brief. 0.19. In the year 2004, what is the difference between the Imports(as % of merchandise exports) in Singapore and Imports(as % of merchandise exports) in Sudan?
Your answer should be compact. 0.81. In the year 2005, what is the difference between the Imports(as % of merchandise exports) of Lebanon and Imports(as % of merchandise exports) of New Zealand?
Offer a terse response. 0.52. In the year 2005, what is the difference between the Imports(as % of merchandise exports) of Lebanon and Imports(as % of merchandise exports) of Singapore?
Provide a short and direct response. 0.59. In the year 2005, what is the difference between the Imports(as % of merchandise exports) in Lebanon and Imports(as % of merchandise exports) in Sudan?
Ensure brevity in your answer.  1.3. In the year 2005, what is the difference between the Imports(as % of merchandise exports) in New Zealand and Imports(as % of merchandise exports) in Singapore?
Offer a terse response. 0.07. In the year 2005, what is the difference between the Imports(as % of merchandise exports) of New Zealand and Imports(as % of merchandise exports) of Sudan?
Offer a very short reply. 0.77. In the year 2005, what is the difference between the Imports(as % of merchandise exports) in Singapore and Imports(as % of merchandise exports) in Sudan?
Give a very brief answer. 0.7. What is the ratio of the Imports(as % of merchandise exports) in Lebanon in 1999 to that in 2000?
Provide a succinct answer. 0.94. What is the ratio of the Imports(as % of merchandise exports) in New Zealand in 1999 to that in 2000?
Offer a terse response. 0.95. What is the ratio of the Imports(as % of merchandise exports) in Sudan in 1999 to that in 2000?
Offer a very short reply. 0.8. What is the ratio of the Imports(as % of merchandise exports) of Lebanon in 1999 to that in 2001?
Keep it short and to the point. 1.07. What is the ratio of the Imports(as % of merchandise exports) of New Zealand in 1999 to that in 2001?
Provide a short and direct response. 0.99. What is the ratio of the Imports(as % of merchandise exports) of Singapore in 1999 to that in 2001?
Ensure brevity in your answer.  0.92. What is the ratio of the Imports(as % of merchandise exports) of Sudan in 1999 to that in 2001?
Your response must be concise. 0.82. What is the ratio of the Imports(as % of merchandise exports) in Lebanon in 1999 to that in 2002?
Provide a short and direct response. 1. What is the ratio of the Imports(as % of merchandise exports) in New Zealand in 1999 to that in 2002?
Provide a short and direct response. 1.07. What is the ratio of the Imports(as % of merchandise exports) in Singapore in 1999 to that in 2002?
Keep it short and to the point. 1. What is the ratio of the Imports(as % of merchandise exports) in Sudan in 1999 to that in 2002?
Your response must be concise. 0.75. What is the ratio of the Imports(as % of merchandise exports) in Lebanon in 1999 to that in 2003?
Give a very brief answer. 0.9. What is the ratio of the Imports(as % of merchandise exports) of Singapore in 1999 to that in 2003?
Provide a short and direct response. 1.19. What is the ratio of the Imports(as % of merchandise exports) in Sudan in 1999 to that in 2003?
Your answer should be compact. 0.82. What is the ratio of the Imports(as % of merchandise exports) of Lebanon in 1999 to that in 2004?
Make the answer very short. 0.94. What is the ratio of the Imports(as % of merchandise exports) in New Zealand in 1999 to that in 2004?
Ensure brevity in your answer.  1.14. What is the ratio of the Imports(as % of merchandise exports) of Sudan in 1999 to that in 2004?
Give a very brief answer. 0.84. What is the ratio of the Imports(as % of merchandise exports) in Lebanon in 1999 to that in 2005?
Your response must be concise. 0.96. What is the ratio of the Imports(as % of merchandise exports) of New Zealand in 1999 to that in 2005?
Offer a terse response. 1.19. What is the ratio of the Imports(as % of merchandise exports) of Singapore in 1999 to that in 2005?
Make the answer very short. 0.97. What is the ratio of the Imports(as % of merchandise exports) of Sudan in 1999 to that in 2005?
Your answer should be very brief. 0.7. What is the ratio of the Imports(as % of merchandise exports) of Lebanon in 2000 to that in 2001?
Keep it short and to the point. 1.14. What is the ratio of the Imports(as % of merchandise exports) in New Zealand in 2000 to that in 2001?
Offer a very short reply. 1.04. What is the ratio of the Imports(as % of merchandise exports) in Singapore in 2000 to that in 2001?
Make the answer very short. 0.93. What is the ratio of the Imports(as % of merchandise exports) of Sudan in 2000 to that in 2001?
Make the answer very short. 1.02. What is the ratio of the Imports(as % of merchandise exports) of Lebanon in 2000 to that in 2002?
Provide a succinct answer. 1.06. What is the ratio of the Imports(as % of merchandise exports) in New Zealand in 2000 to that in 2002?
Provide a succinct answer. 1.12. What is the ratio of the Imports(as % of merchandise exports) in Singapore in 2000 to that in 2002?
Ensure brevity in your answer.  1.01. What is the ratio of the Imports(as % of merchandise exports) of Sudan in 2000 to that in 2002?
Ensure brevity in your answer.  0.94. What is the ratio of the Imports(as % of merchandise exports) in Lebanon in 2000 to that in 2003?
Offer a very short reply. 0.95. What is the ratio of the Imports(as % of merchandise exports) in New Zealand in 2000 to that in 2003?
Give a very brief answer. 1.2. What is the ratio of the Imports(as % of merchandise exports) in Singapore in 2000 to that in 2003?
Ensure brevity in your answer.  1.2. What is the ratio of the Imports(as % of merchandise exports) of Sudan in 2000 to that in 2003?
Keep it short and to the point. 1.02. What is the ratio of the Imports(as % of merchandise exports) in New Zealand in 2000 to that in 2004?
Ensure brevity in your answer.  1.19. What is the ratio of the Imports(as % of merchandise exports) of Singapore in 2000 to that in 2004?
Provide a short and direct response. 1.01. What is the ratio of the Imports(as % of merchandise exports) in Sudan in 2000 to that in 2004?
Give a very brief answer. 1.04. What is the ratio of the Imports(as % of merchandise exports) of Lebanon in 2000 to that in 2005?
Your response must be concise. 1.02. What is the ratio of the Imports(as % of merchandise exports) in New Zealand in 2000 to that in 2005?
Provide a short and direct response. 1.25. What is the ratio of the Imports(as % of merchandise exports) in Singapore in 2000 to that in 2005?
Offer a terse response. 0.98. What is the ratio of the Imports(as % of merchandise exports) of Sudan in 2000 to that in 2005?
Offer a very short reply. 0.87. What is the ratio of the Imports(as % of merchandise exports) of Lebanon in 2001 to that in 2002?
Your answer should be very brief. 0.93. What is the ratio of the Imports(as % of merchandise exports) in New Zealand in 2001 to that in 2002?
Your response must be concise. 1.08. What is the ratio of the Imports(as % of merchandise exports) of Singapore in 2001 to that in 2002?
Keep it short and to the point. 1.08. What is the ratio of the Imports(as % of merchandise exports) in Sudan in 2001 to that in 2002?
Your answer should be very brief. 0.92. What is the ratio of the Imports(as % of merchandise exports) in Lebanon in 2001 to that in 2003?
Make the answer very short. 0.84. What is the ratio of the Imports(as % of merchandise exports) of New Zealand in 2001 to that in 2003?
Offer a very short reply. 1.16. What is the ratio of the Imports(as % of merchandise exports) of Singapore in 2001 to that in 2003?
Ensure brevity in your answer.  1.29. What is the ratio of the Imports(as % of merchandise exports) of Sudan in 2001 to that in 2003?
Your answer should be compact. 1. What is the ratio of the Imports(as % of merchandise exports) of Lebanon in 2001 to that in 2004?
Offer a very short reply. 0.88. What is the ratio of the Imports(as % of merchandise exports) of New Zealand in 2001 to that in 2004?
Provide a succinct answer. 1.15. What is the ratio of the Imports(as % of merchandise exports) in Singapore in 2001 to that in 2004?
Provide a short and direct response. 1.08. What is the ratio of the Imports(as % of merchandise exports) of Sudan in 2001 to that in 2004?
Ensure brevity in your answer.  1.02. What is the ratio of the Imports(as % of merchandise exports) in Lebanon in 2001 to that in 2005?
Ensure brevity in your answer.  0.89. What is the ratio of the Imports(as % of merchandise exports) of New Zealand in 2001 to that in 2005?
Make the answer very short. 1.2. What is the ratio of the Imports(as % of merchandise exports) in Singapore in 2001 to that in 2005?
Your response must be concise. 1.05. What is the ratio of the Imports(as % of merchandise exports) of Sudan in 2001 to that in 2005?
Your answer should be very brief. 0.85. What is the ratio of the Imports(as % of merchandise exports) of Lebanon in 2002 to that in 2003?
Ensure brevity in your answer.  0.9. What is the ratio of the Imports(as % of merchandise exports) in New Zealand in 2002 to that in 2003?
Your answer should be very brief. 1.07. What is the ratio of the Imports(as % of merchandise exports) of Singapore in 2002 to that in 2003?
Your response must be concise. 1.19. What is the ratio of the Imports(as % of merchandise exports) of Sudan in 2002 to that in 2003?
Provide a short and direct response. 1.09. What is the ratio of the Imports(as % of merchandise exports) in Lebanon in 2002 to that in 2004?
Make the answer very short. 0.95. What is the ratio of the Imports(as % of merchandise exports) of New Zealand in 2002 to that in 2004?
Ensure brevity in your answer.  1.06. What is the ratio of the Imports(as % of merchandise exports) in Singapore in 2002 to that in 2004?
Give a very brief answer. 1. What is the ratio of the Imports(as % of merchandise exports) in Sudan in 2002 to that in 2004?
Your answer should be compact. 1.11. What is the ratio of the Imports(as % of merchandise exports) of Lebanon in 2002 to that in 2005?
Make the answer very short. 0.96. What is the ratio of the Imports(as % of merchandise exports) of New Zealand in 2002 to that in 2005?
Offer a terse response. 1.11. What is the ratio of the Imports(as % of merchandise exports) in Singapore in 2002 to that in 2005?
Offer a very short reply. 0.97. What is the ratio of the Imports(as % of merchandise exports) in Sudan in 2002 to that in 2005?
Make the answer very short. 0.93. What is the ratio of the Imports(as % of merchandise exports) of Lebanon in 2003 to that in 2004?
Your response must be concise. 1.05. What is the ratio of the Imports(as % of merchandise exports) of Singapore in 2003 to that in 2004?
Your response must be concise. 0.84. What is the ratio of the Imports(as % of merchandise exports) in Sudan in 2003 to that in 2004?
Make the answer very short. 1.02. What is the ratio of the Imports(as % of merchandise exports) in Lebanon in 2003 to that in 2005?
Your answer should be compact. 1.07. What is the ratio of the Imports(as % of merchandise exports) in New Zealand in 2003 to that in 2005?
Your answer should be very brief. 1.04. What is the ratio of the Imports(as % of merchandise exports) of Singapore in 2003 to that in 2005?
Provide a short and direct response. 0.82. What is the ratio of the Imports(as % of merchandise exports) of Sudan in 2003 to that in 2005?
Your response must be concise. 0.85. What is the ratio of the Imports(as % of merchandise exports) in Lebanon in 2004 to that in 2005?
Offer a terse response. 1.02. What is the ratio of the Imports(as % of merchandise exports) in New Zealand in 2004 to that in 2005?
Offer a terse response. 1.04. What is the ratio of the Imports(as % of merchandise exports) in Singapore in 2004 to that in 2005?
Your answer should be very brief. 0.97. What is the ratio of the Imports(as % of merchandise exports) of Sudan in 2004 to that in 2005?
Offer a very short reply. 0.83. What is the difference between the highest and the second highest Imports(as % of merchandise exports) in Lebanon?
Ensure brevity in your answer.  0.11. What is the difference between the highest and the second highest Imports(as % of merchandise exports) of New Zealand?
Offer a terse response. 0.07. What is the difference between the highest and the second highest Imports(as % of merchandise exports) in Singapore?
Keep it short and to the point. 0.09. What is the difference between the highest and the second highest Imports(as % of merchandise exports) in Sudan?
Ensure brevity in your answer.  0.07. What is the difference between the highest and the lowest Imports(as % of merchandise exports) in Lebanon?
Your response must be concise. 0.39. What is the difference between the highest and the lowest Imports(as % of merchandise exports) in New Zealand?
Ensure brevity in your answer.  0.42. What is the difference between the highest and the lowest Imports(as % of merchandise exports) in Singapore?
Provide a short and direct response. 0.38. What is the difference between the highest and the lowest Imports(as % of merchandise exports) in Sudan?
Give a very brief answer. 0.28. 